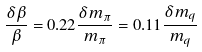Convert formula to latex. <formula><loc_0><loc_0><loc_500><loc_500>\frac { \delta \beta } { \beta } = 0 . 2 2 \frac { \delta m _ { \pi } } { m _ { \pi } } = 0 . 1 1 \frac { \delta m _ { q } } { m _ { q } }</formula> 